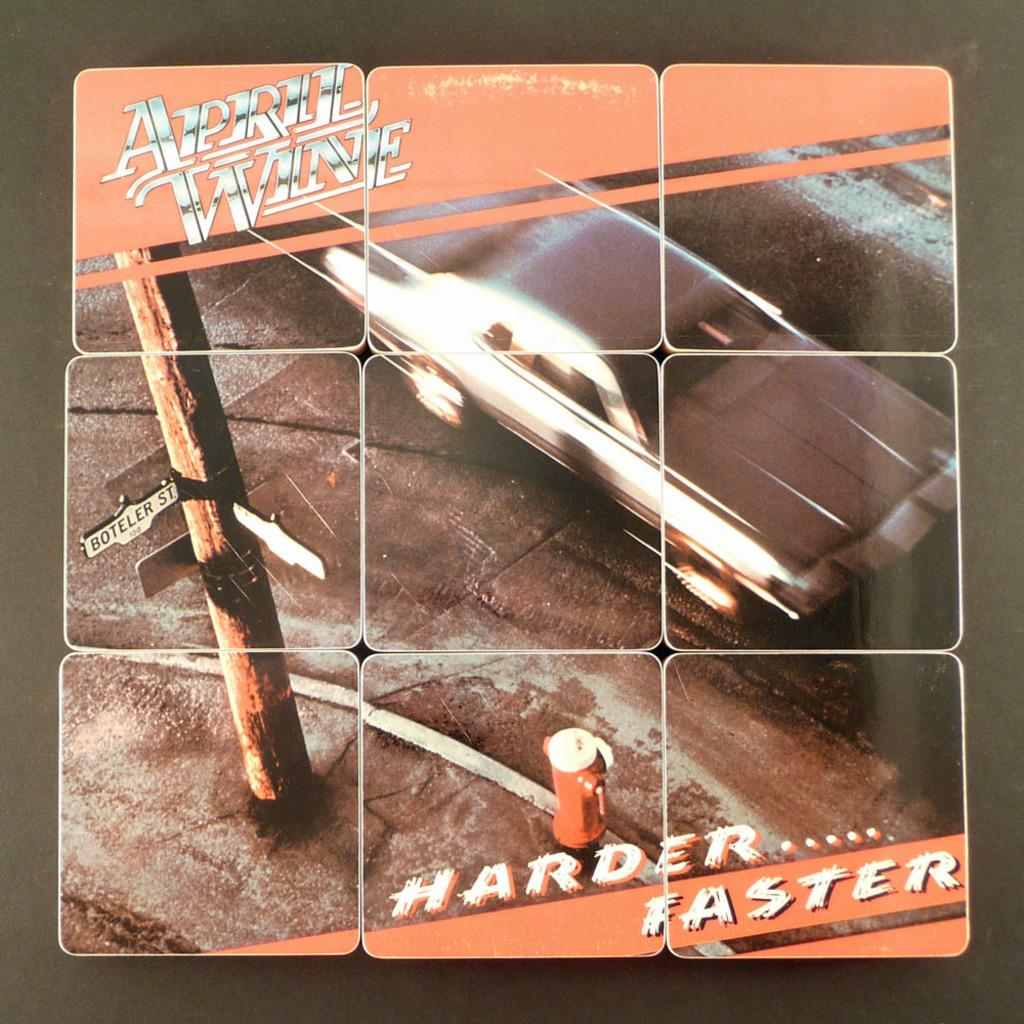<image>
Offer a succinct explanation of the picture presented. a set of pictures placed together that says 'april wine' 